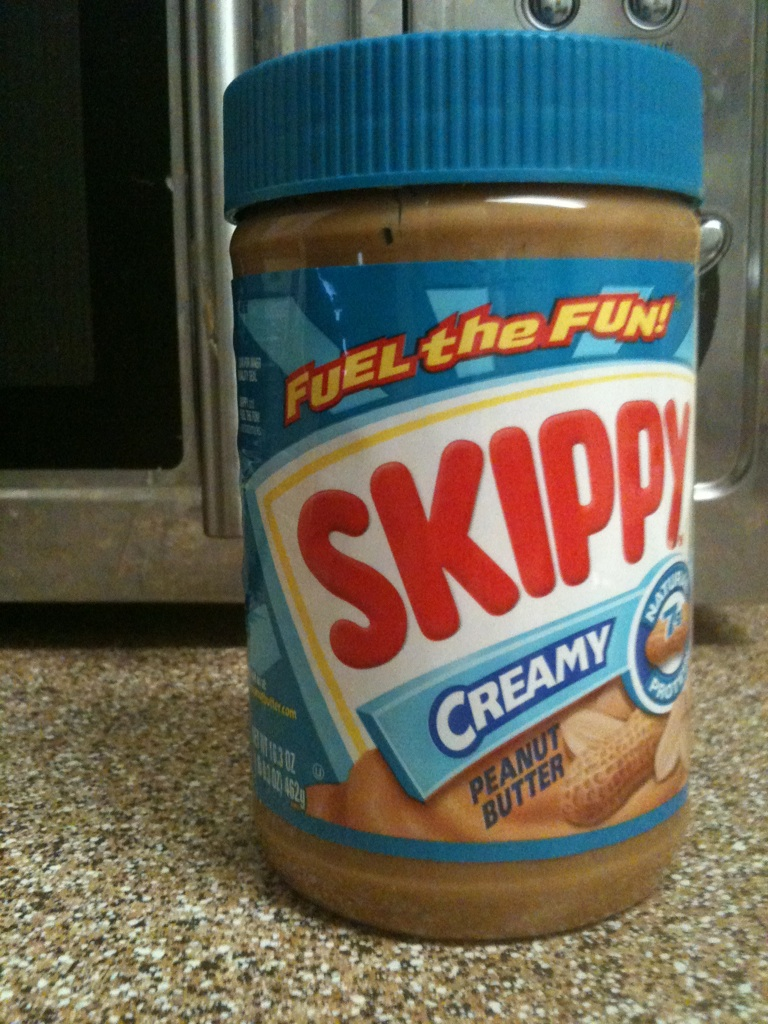Are there any recipes that specifically recommend using this brand of peanut butter? Yes, Skippy peanut butter is often recommended for a variety of recipes, from peanut butter cookies to smoothies. It's prized for its creamy texture which blends smoothly into batters and mixes, and maintains a good balance of flavor in dishes that call for peanut butter. Can you suggest a simple recipe using Skippy peanut butter? Certainly! For a quick and delicious treat, try making peanut butter banana smoothies. Just blend two ripe bananas, one cup of milk, two tablespoons of Skippy Creamy Peanut Butter, and ice cubes until smooth. It’s refreshing and nutritious! 